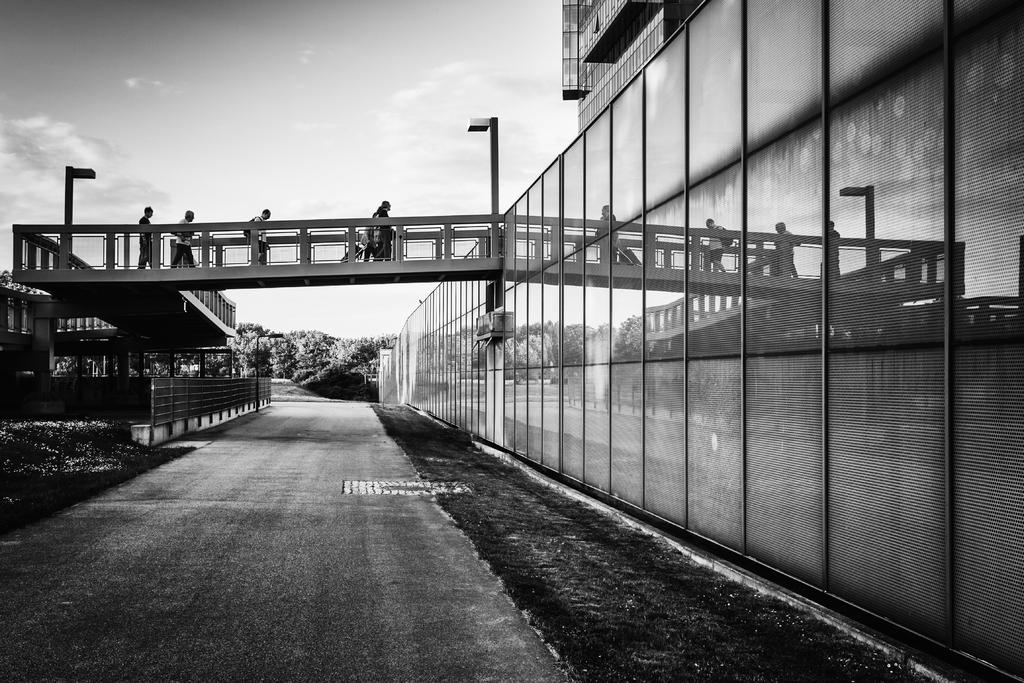What is the color scheme of the image? The image is black and white. What are the people in the image doing? The people in the image are walking on a bridge. What type of vegetation can be seen in the image? There are trees in the image. What structures are present in the image? There are poles, a wall, and a building in the image. What type of ground surface is visible in the image? There is grass in the image. What nation is being discussed by the people walking on the bridge in the image? There is no indication in the image that the people are discussing any nation. 